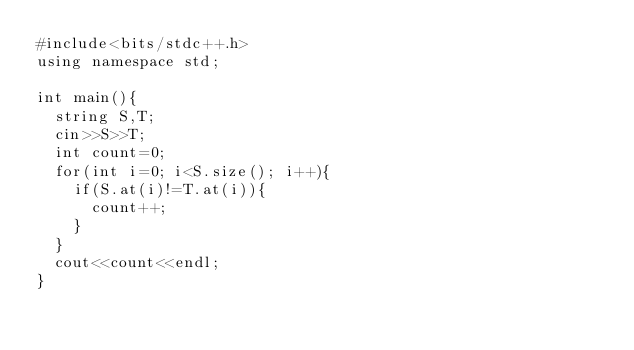Convert code to text. <code><loc_0><loc_0><loc_500><loc_500><_C++_>#include<bits/stdc++.h>
using namespace std;

int main(){
  string S,T;
  cin>>S>>T;
  int count=0;
  for(int i=0; i<S.size(); i++){
    if(S.at(i)!=T.at(i)){
      count++;
    }
  }
  cout<<count<<endl;
}</code> 